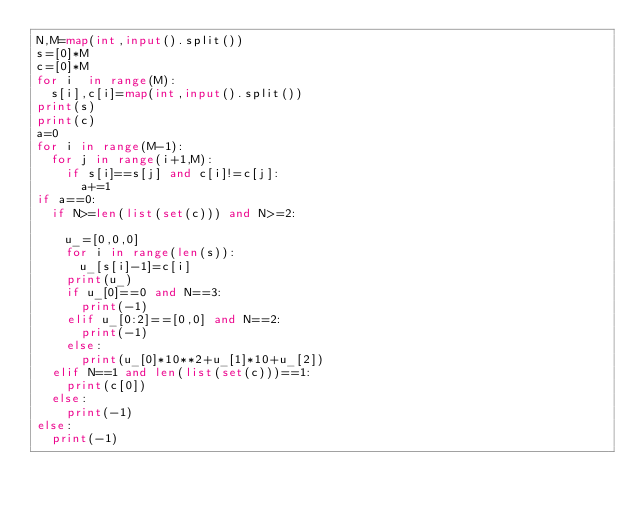Convert code to text. <code><loc_0><loc_0><loc_500><loc_500><_Python_>N,M=map(int,input().split())
s=[0]*M
c=[0]*M
for i  in range(M):
  s[i],c[i]=map(int,input().split())
print(s)
print(c)
a=0
for i in range(M-1):
  for j in range(i+1,M):
    if s[i]==s[j] and c[i]!=c[j]:
      a+=1
if a==0:
  if N>=len(list(set(c))) and N>=2:
    
    u_=[0,0,0]
    for i in range(len(s)):
      u_[s[i]-1]=c[i]
    print(u_)  
    if u_[0]==0 and N==3:
      print(-1)
    elif u_[0:2]==[0,0] and N==2:
      print(-1)
    else:
      print(u_[0]*10**2+u_[1]*10+u_[2])
  elif N==1 and len(list(set(c)))==1:
    print(c[0])
  else:
    print(-1)
else:
  print(-1)</code> 